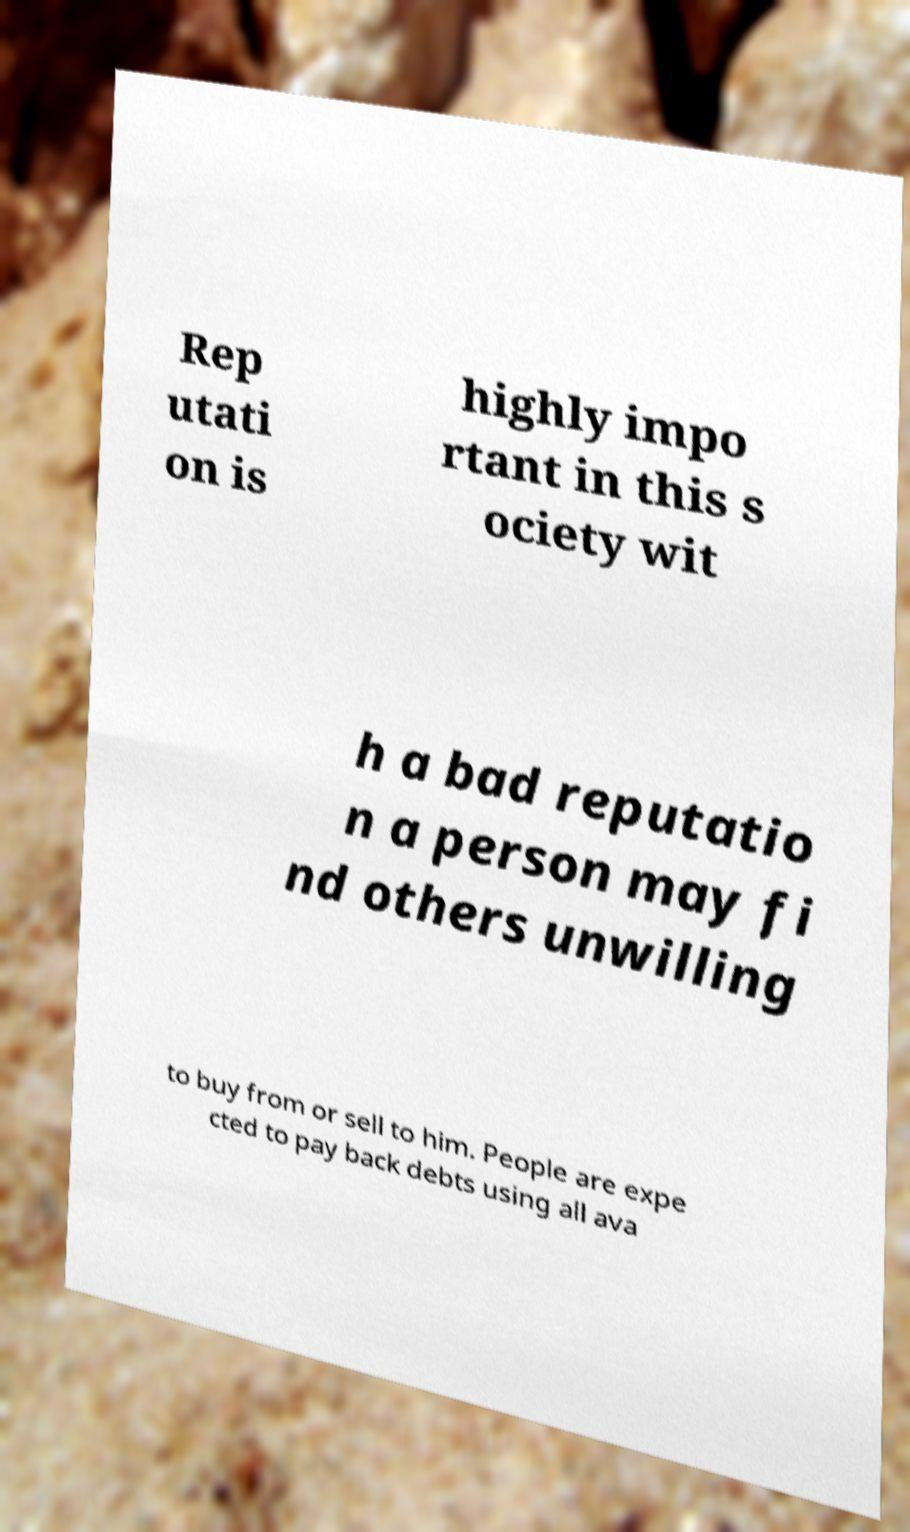What messages or text are displayed in this image? I need them in a readable, typed format. Rep utati on is highly impo rtant in this s ociety wit h a bad reputatio n a person may fi nd others unwilling to buy from or sell to him. People are expe cted to pay back debts using all ava 